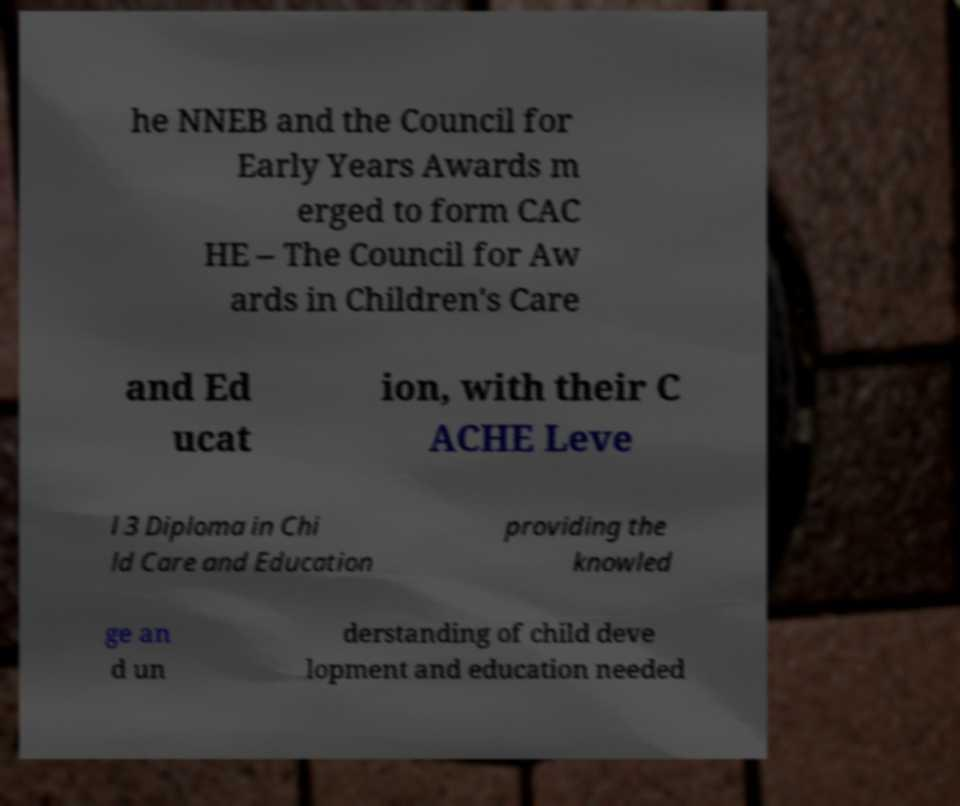Could you assist in decoding the text presented in this image and type it out clearly? he NNEB and the Council for Early Years Awards m erged to form CAC HE – The Council for Aw ards in Children's Care and Ed ucat ion, with their C ACHE Leve l 3 Diploma in Chi ld Care and Education providing the knowled ge an d un derstanding of child deve lopment and education needed 